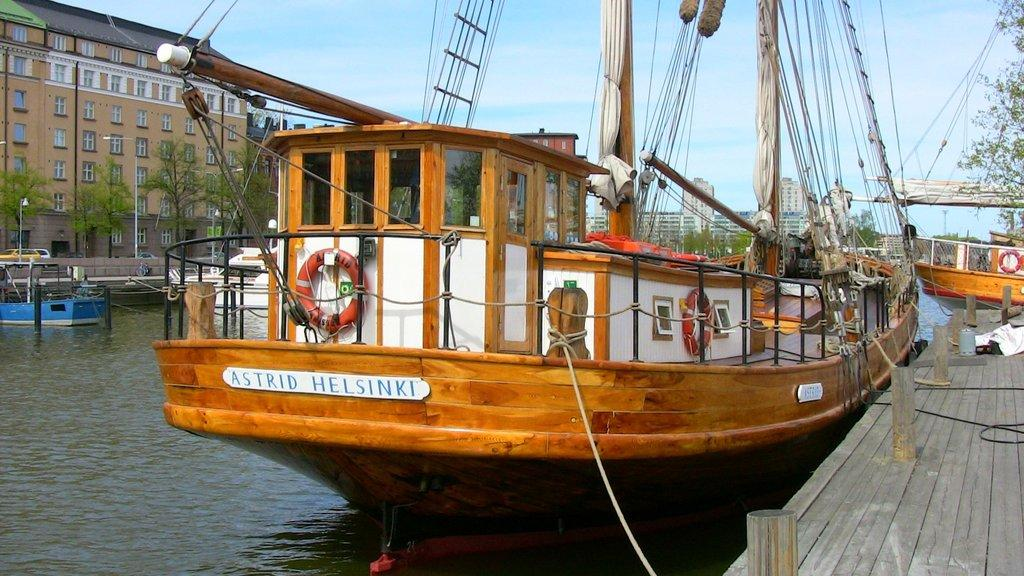What type of location is depicted in the picture? There is a boat yard in the picture. What can be seen on the water in the image? There are boats on the water. What is visible in the background of the image? Buildings, trees, street lights, and the sky are visible in the background. Can you describe any other objects in the background? There are other objects in the background, but their specific details are not mentioned in the provided facts. How many friends are sitting on the donkey in the image? There is no donkey or friends present in the image. What word is written on the side of the boat in the image? The provided facts do not mention any words written on the boats, so it cannot be determined from the image. 